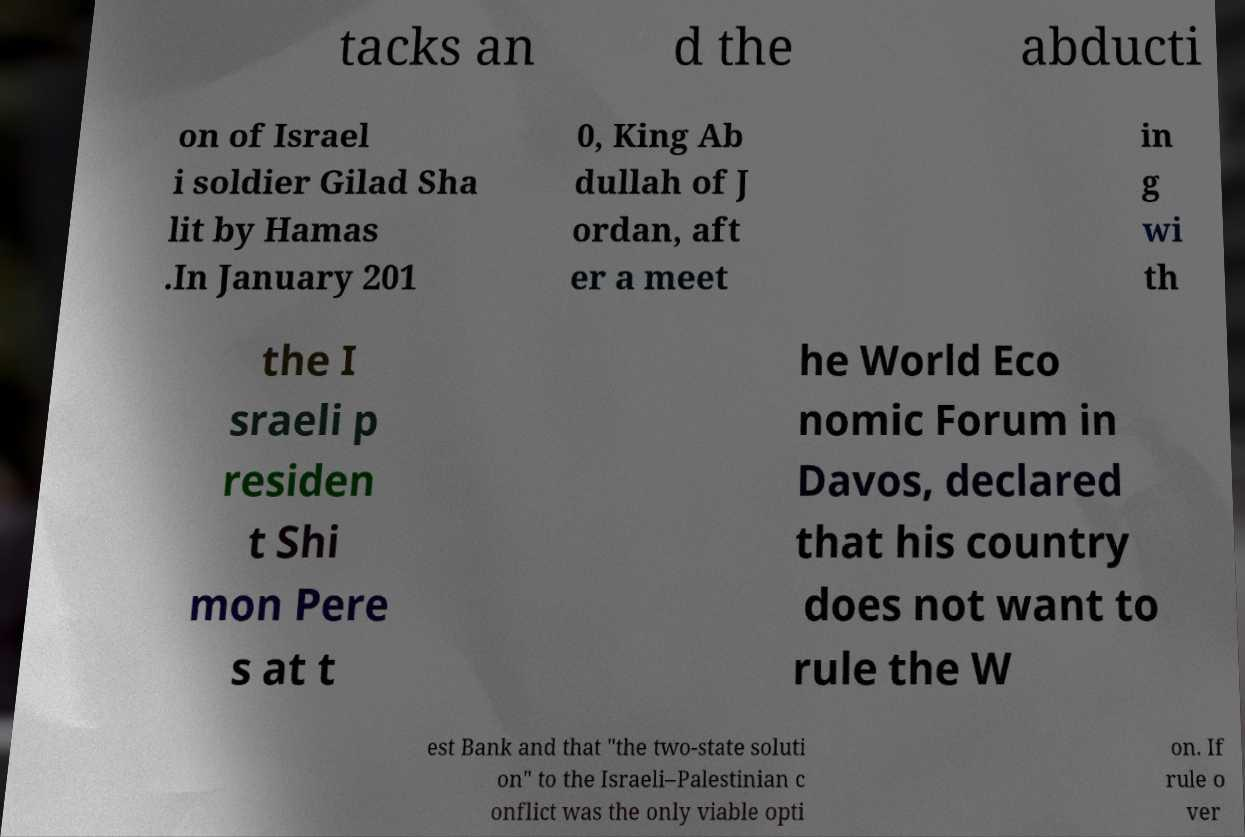Can you accurately transcribe the text from the provided image for me? tacks an d the abducti on of Israel i soldier Gilad Sha lit by Hamas .In January 201 0, King Ab dullah of J ordan, aft er a meet in g wi th the I sraeli p residen t Shi mon Pere s at t he World Eco nomic Forum in Davos, declared that his country does not want to rule the W est Bank and that "the two-state soluti on" to the Israeli–Palestinian c onflict was the only viable opti on. If rule o ver 